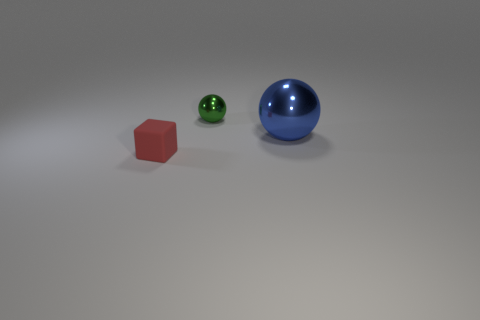Add 2 big blue objects. How many objects exist? 5 Subtract all cubes. How many objects are left? 2 Add 2 small metal things. How many small metal things are left? 3 Add 1 cyan cylinders. How many cyan cylinders exist? 1 Subtract 0 gray cylinders. How many objects are left? 3 Subtract all purple balls. Subtract all small things. How many objects are left? 1 